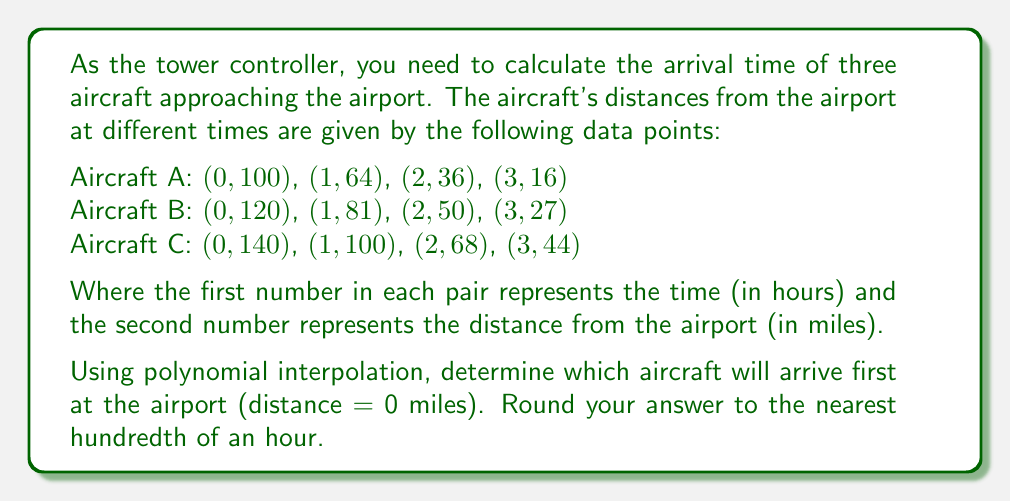Help me with this question. To solve this problem, we need to follow these steps for each aircraft:

1. Find the polynomial function that fits the given data points.
2. Solve the equation when the distance (y) equals 0 to find the arrival time.

Let's start with Aircraft A:

1. We can use Lagrange interpolation to find the polynomial function. The general form is:
   $$P(x) = \sum_{i=0}^n y_i \prod_{j=0, j \neq i}^n \frac{x - x_j}{x_i - x_j}$$

2. Calculating for Aircraft A:
   $$P_A(x) = 100\frac{(x-1)(x-2)(x-3)}{(0-1)(0-2)(0-3)} + 64\frac{(x-0)(x-2)(x-3)}{(1-0)(1-2)(1-3)} + 36\frac{(x-0)(x-1)(x-3)}{(2-0)(2-1)(2-3)} + 16\frac{(x-0)(x-1)(x-2)}{(3-0)(3-1)(3-2)}$$

3. Simplifying:
   $$P_A(x) = 100 - 54x + 8x^2 - \frac{1}{3}x^3$$

4. To find the arrival time, solve $P_A(x) = 0$:
   $$100 - 54x + 8x^2 - \frac{1}{3}x^3 = 0$$

5. Using a numerical method (e.g., Newton-Raphson), we find x ≈ 3.7321 hours.

Repeating the process for Aircraft B and C:

Aircraft B:
$$P_B(x) = 120 - 66x + 10x^2 - \frac{1}{3}x^3$$
Arrival time: x ≈ 3.9679 hours

Aircraft C:
$$P_C(x) = 140 - 78x + 12x^2 - \frac{1}{3}x^3$$
Arrival time: x ≈ 4.2038 hours

Therefore, Aircraft A will arrive first at approximately 3.73 hours.
Answer: 3.73 hours 